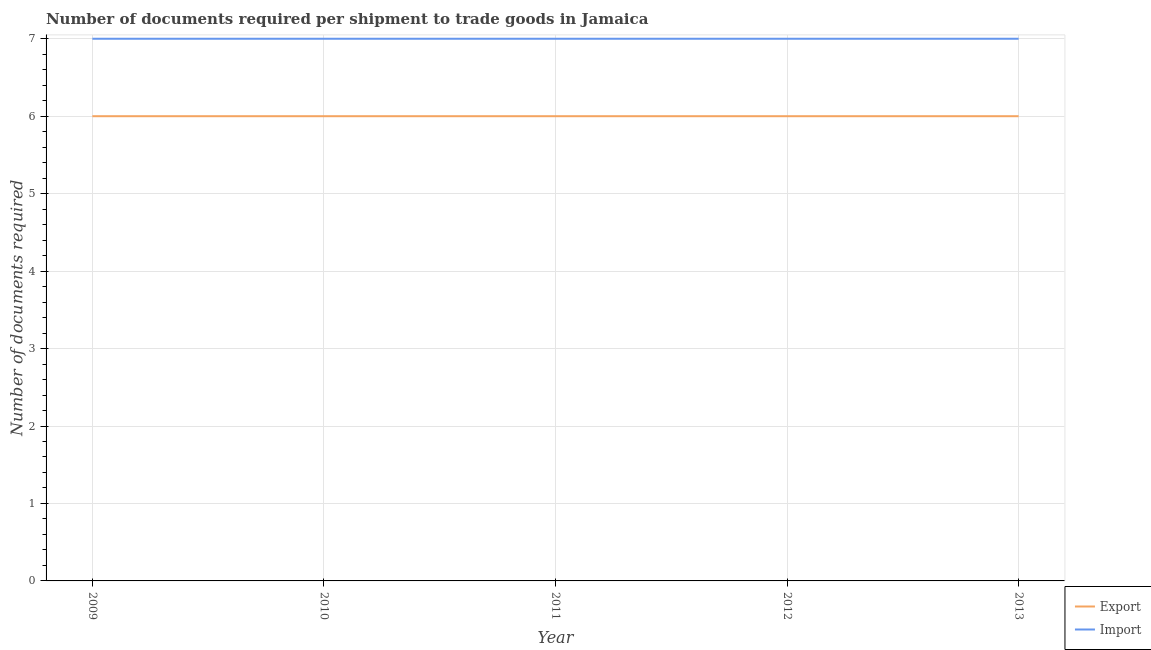Is the number of lines equal to the number of legend labels?
Make the answer very short. Yes. What is the number of documents required to import goods in 2010?
Make the answer very short. 7. Across all years, what is the minimum number of documents required to import goods?
Make the answer very short. 7. In which year was the number of documents required to export goods maximum?
Keep it short and to the point. 2009. What is the total number of documents required to import goods in the graph?
Provide a succinct answer. 35. What is the difference between the number of documents required to export goods in 2012 and the number of documents required to import goods in 2013?
Your answer should be very brief. -1. What is the average number of documents required to export goods per year?
Your answer should be very brief. 6. In the year 2011, what is the difference between the number of documents required to export goods and number of documents required to import goods?
Offer a terse response. -1. Is the number of documents required to export goods in 2011 less than that in 2013?
Your answer should be compact. No. In how many years, is the number of documents required to export goods greater than the average number of documents required to export goods taken over all years?
Provide a succinct answer. 0. Does the number of documents required to import goods monotonically increase over the years?
Make the answer very short. No. How many lines are there?
Your answer should be very brief. 2. How many years are there in the graph?
Your answer should be compact. 5. Are the values on the major ticks of Y-axis written in scientific E-notation?
Provide a succinct answer. No. Does the graph contain grids?
Your answer should be very brief. Yes. Where does the legend appear in the graph?
Give a very brief answer. Bottom right. How many legend labels are there?
Make the answer very short. 2. How are the legend labels stacked?
Offer a terse response. Vertical. What is the title of the graph?
Make the answer very short. Number of documents required per shipment to trade goods in Jamaica. Does "Mobile cellular" appear as one of the legend labels in the graph?
Provide a succinct answer. No. What is the label or title of the Y-axis?
Keep it short and to the point. Number of documents required. What is the Number of documents required in Export in 2009?
Your answer should be very brief. 6. What is the Number of documents required in Export in 2010?
Offer a very short reply. 6. What is the Number of documents required of Export in 2012?
Keep it short and to the point. 6. What is the Number of documents required in Export in 2013?
Your answer should be very brief. 6. What is the Number of documents required of Import in 2013?
Your answer should be very brief. 7. Across all years, what is the maximum Number of documents required in Export?
Your answer should be very brief. 6. Across all years, what is the maximum Number of documents required in Import?
Provide a short and direct response. 7. Across all years, what is the minimum Number of documents required of Import?
Make the answer very short. 7. What is the total Number of documents required in Import in the graph?
Offer a very short reply. 35. What is the difference between the Number of documents required in Export in 2009 and that in 2012?
Provide a succinct answer. 0. What is the difference between the Number of documents required in Import in 2009 and that in 2012?
Give a very brief answer. 0. What is the difference between the Number of documents required in Export in 2009 and that in 2013?
Provide a short and direct response. 0. What is the difference between the Number of documents required in Import in 2009 and that in 2013?
Ensure brevity in your answer.  0. What is the difference between the Number of documents required of Import in 2010 and that in 2011?
Make the answer very short. 0. What is the difference between the Number of documents required of Export in 2010 and that in 2012?
Keep it short and to the point. 0. What is the difference between the Number of documents required of Export in 2010 and that in 2013?
Your answer should be compact. 0. What is the difference between the Number of documents required in Import in 2010 and that in 2013?
Offer a terse response. 0. What is the difference between the Number of documents required in Export in 2011 and that in 2012?
Give a very brief answer. 0. What is the difference between the Number of documents required of Export in 2012 and that in 2013?
Keep it short and to the point. 0. What is the difference between the Number of documents required of Export in 2009 and the Number of documents required of Import in 2011?
Your answer should be very brief. -1. What is the difference between the Number of documents required of Export in 2010 and the Number of documents required of Import in 2013?
Make the answer very short. -1. What is the difference between the Number of documents required of Export in 2012 and the Number of documents required of Import in 2013?
Provide a short and direct response. -1. In the year 2009, what is the difference between the Number of documents required in Export and Number of documents required in Import?
Provide a succinct answer. -1. What is the ratio of the Number of documents required of Import in 2009 to that in 2010?
Your answer should be compact. 1. What is the ratio of the Number of documents required of Import in 2009 to that in 2011?
Offer a very short reply. 1. What is the ratio of the Number of documents required of Export in 2009 to that in 2012?
Your answer should be very brief. 1. What is the ratio of the Number of documents required in Import in 2010 to that in 2012?
Give a very brief answer. 1. What is the ratio of the Number of documents required in Export in 2010 to that in 2013?
Make the answer very short. 1. What is the ratio of the Number of documents required in Import in 2011 to that in 2012?
Ensure brevity in your answer.  1. What is the ratio of the Number of documents required in Import in 2011 to that in 2013?
Offer a very short reply. 1. What is the difference between the highest and the second highest Number of documents required of Export?
Provide a short and direct response. 0. What is the difference between the highest and the lowest Number of documents required of Export?
Your answer should be compact. 0. 